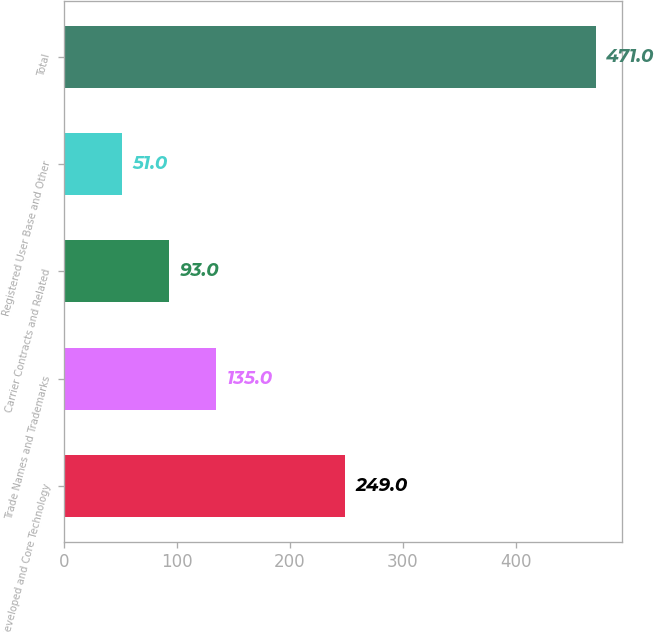Convert chart to OTSL. <chart><loc_0><loc_0><loc_500><loc_500><bar_chart><fcel>Developed and Core Technology<fcel>Trade Names and Trademarks<fcel>Carrier Contracts and Related<fcel>Registered User Base and Other<fcel>Total<nl><fcel>249<fcel>135<fcel>93<fcel>51<fcel>471<nl></chart> 